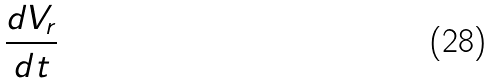<formula> <loc_0><loc_0><loc_500><loc_500>\frac { d V _ { r } } { d t }</formula> 